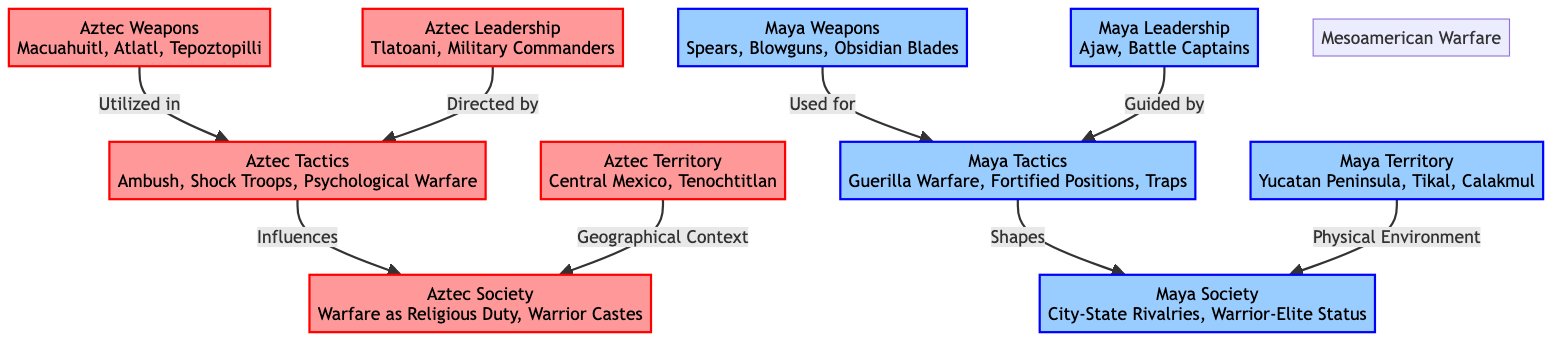What weapons did the Aztecs use? The diagram indicates that the Aztecs utilized the macuahuitl, atlatl, and tepoztopilli as their weapons. This can be found in the "Aztec Weapons" node.
Answer: macuahuitl, atlatl, tepoztopilli What tactics were employed by the Maya? According to the diagram, the Maya employed guerilla warfare, fortified positions, and traps as their battlefield tactics. This information is found in the "Maya Tactics" node.
Answer: Guerilla Warfare, Fortified Positions, Traps How does Aztec warfare influence their society? The diagram shows an arrow from "Aztec Tactics" to "Aztec Society," indicating that Aztec warfare as a religious duty and the establishment of warrior castes are influenced by their tactics.
Answer: Religious Duty, Warrior Castes Who led the Maya during battles? The diagram indicates that the Maya leadership was guided by "Ajaw" and "Battle Captains" in the "Maya Leadership" node.
Answer: Ajaw, Battle Captains What commonality exists between the Aztec and Maya societies? The diagram shows that both societies are influenced by their respective military structures and tactics, suggesting commonalities in the relationship between warfare and society in Mesoamerica.
Answer: Military Structures and Tactics What territory did the Aztecs occupy? The diagram specifies that the Aztecs were located in Central Mexico and centered around Tenochtitlan, as indicated in the "Aztec Territory" node.
Answer: Central Mexico, Tenochtitlan How are Aztec and Maya tactics different based on the diagram? The diagram clearly outlines that Aztec tactics include ambush and psychological warfare, whereas Maya tactics focus on guerilla warfare and fortified positions. Thus, the two sets of tactics reflect different strategic approaches.
Answer: Ambush, Psychological Warfare vs. Guerilla Warfare, Fortified Positions What is directed by Aztec leadership? The flow from "Aztec Leadership" to "Aztec Tactics" suggests that Aztec leadership, represented by Tlatoani and military commanders, directs their battlefield tactics.
Answer: Battlefield Tactics 